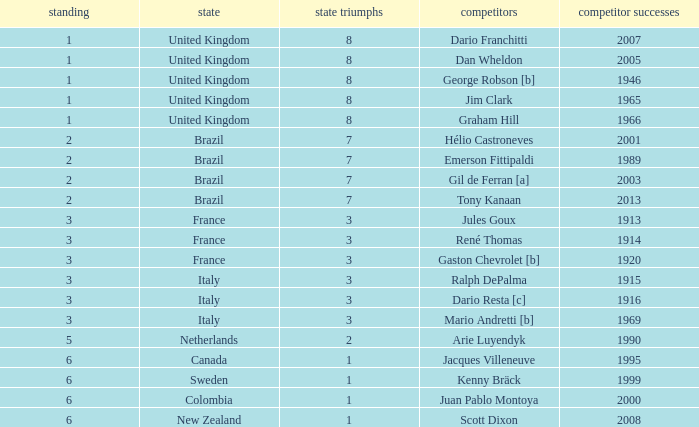What is the average number of wins of drivers from Sweden? 1999.0. 